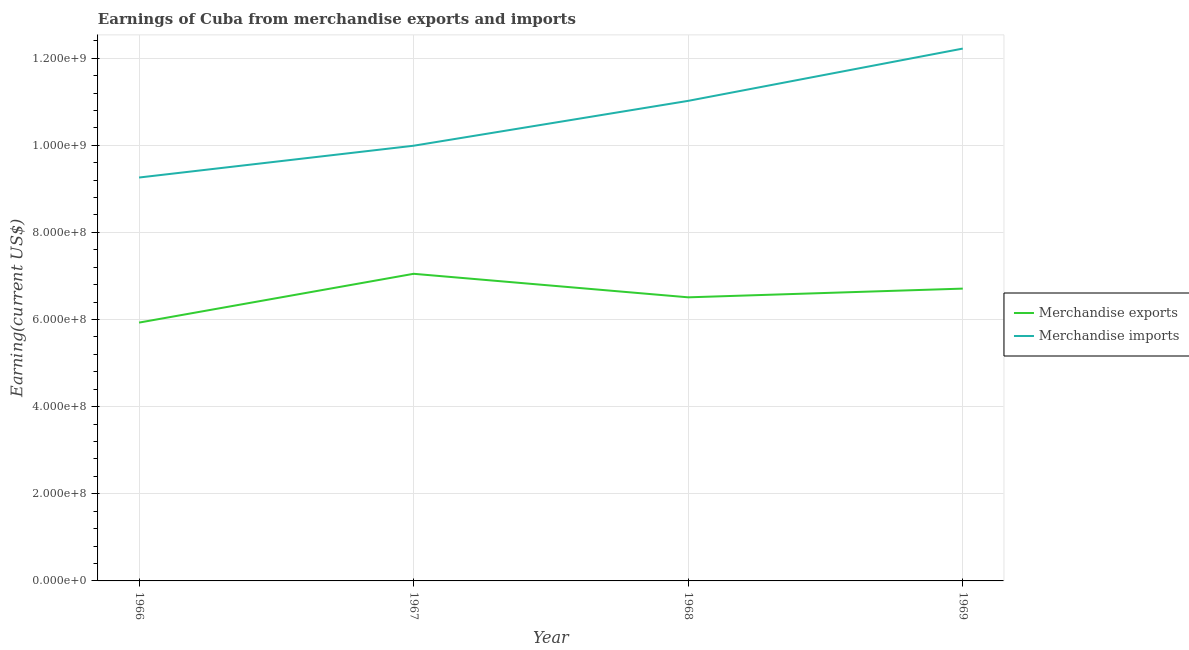How many different coloured lines are there?
Your response must be concise. 2. Is the number of lines equal to the number of legend labels?
Provide a short and direct response. Yes. What is the earnings from merchandise exports in 1966?
Ensure brevity in your answer.  5.93e+08. Across all years, what is the maximum earnings from merchandise exports?
Offer a terse response. 7.05e+08. Across all years, what is the minimum earnings from merchandise imports?
Offer a very short reply. 9.26e+08. In which year was the earnings from merchandise exports maximum?
Your answer should be very brief. 1967. In which year was the earnings from merchandise imports minimum?
Make the answer very short. 1966. What is the total earnings from merchandise imports in the graph?
Ensure brevity in your answer.  4.25e+09. What is the difference between the earnings from merchandise imports in 1966 and that in 1969?
Provide a short and direct response. -2.96e+08. What is the difference between the earnings from merchandise imports in 1969 and the earnings from merchandise exports in 1967?
Ensure brevity in your answer.  5.17e+08. What is the average earnings from merchandise imports per year?
Provide a short and direct response. 1.06e+09. In the year 1967, what is the difference between the earnings from merchandise exports and earnings from merchandise imports?
Provide a succinct answer. -2.94e+08. What is the ratio of the earnings from merchandise imports in 1967 to that in 1968?
Your response must be concise. 0.91. What is the difference between the highest and the second highest earnings from merchandise exports?
Your answer should be compact. 3.40e+07. What is the difference between the highest and the lowest earnings from merchandise imports?
Make the answer very short. 2.96e+08. In how many years, is the earnings from merchandise imports greater than the average earnings from merchandise imports taken over all years?
Give a very brief answer. 2. Is the earnings from merchandise exports strictly greater than the earnings from merchandise imports over the years?
Keep it short and to the point. No. Is the earnings from merchandise exports strictly less than the earnings from merchandise imports over the years?
Offer a very short reply. Yes. How many lines are there?
Offer a terse response. 2. Where does the legend appear in the graph?
Give a very brief answer. Center right. How are the legend labels stacked?
Provide a short and direct response. Vertical. What is the title of the graph?
Your response must be concise. Earnings of Cuba from merchandise exports and imports. Does "Exports" appear as one of the legend labels in the graph?
Keep it short and to the point. No. What is the label or title of the X-axis?
Ensure brevity in your answer.  Year. What is the label or title of the Y-axis?
Offer a very short reply. Earning(current US$). What is the Earning(current US$) of Merchandise exports in 1966?
Offer a terse response. 5.93e+08. What is the Earning(current US$) in Merchandise imports in 1966?
Your answer should be very brief. 9.26e+08. What is the Earning(current US$) of Merchandise exports in 1967?
Your answer should be compact. 7.05e+08. What is the Earning(current US$) of Merchandise imports in 1967?
Offer a very short reply. 9.99e+08. What is the Earning(current US$) of Merchandise exports in 1968?
Your answer should be very brief. 6.51e+08. What is the Earning(current US$) in Merchandise imports in 1968?
Offer a very short reply. 1.10e+09. What is the Earning(current US$) of Merchandise exports in 1969?
Offer a very short reply. 6.71e+08. What is the Earning(current US$) in Merchandise imports in 1969?
Offer a terse response. 1.22e+09. Across all years, what is the maximum Earning(current US$) of Merchandise exports?
Your answer should be compact. 7.05e+08. Across all years, what is the maximum Earning(current US$) of Merchandise imports?
Offer a terse response. 1.22e+09. Across all years, what is the minimum Earning(current US$) in Merchandise exports?
Ensure brevity in your answer.  5.93e+08. Across all years, what is the minimum Earning(current US$) in Merchandise imports?
Give a very brief answer. 9.26e+08. What is the total Earning(current US$) in Merchandise exports in the graph?
Provide a short and direct response. 2.62e+09. What is the total Earning(current US$) of Merchandise imports in the graph?
Make the answer very short. 4.25e+09. What is the difference between the Earning(current US$) of Merchandise exports in 1966 and that in 1967?
Your response must be concise. -1.12e+08. What is the difference between the Earning(current US$) in Merchandise imports in 1966 and that in 1967?
Keep it short and to the point. -7.30e+07. What is the difference between the Earning(current US$) in Merchandise exports in 1966 and that in 1968?
Make the answer very short. -5.80e+07. What is the difference between the Earning(current US$) in Merchandise imports in 1966 and that in 1968?
Provide a short and direct response. -1.76e+08. What is the difference between the Earning(current US$) in Merchandise exports in 1966 and that in 1969?
Ensure brevity in your answer.  -7.80e+07. What is the difference between the Earning(current US$) in Merchandise imports in 1966 and that in 1969?
Ensure brevity in your answer.  -2.96e+08. What is the difference between the Earning(current US$) in Merchandise exports in 1967 and that in 1968?
Offer a terse response. 5.40e+07. What is the difference between the Earning(current US$) in Merchandise imports in 1967 and that in 1968?
Your response must be concise. -1.03e+08. What is the difference between the Earning(current US$) in Merchandise exports in 1967 and that in 1969?
Provide a short and direct response. 3.40e+07. What is the difference between the Earning(current US$) in Merchandise imports in 1967 and that in 1969?
Your response must be concise. -2.23e+08. What is the difference between the Earning(current US$) in Merchandise exports in 1968 and that in 1969?
Provide a short and direct response. -2.00e+07. What is the difference between the Earning(current US$) of Merchandise imports in 1968 and that in 1969?
Make the answer very short. -1.20e+08. What is the difference between the Earning(current US$) of Merchandise exports in 1966 and the Earning(current US$) of Merchandise imports in 1967?
Make the answer very short. -4.06e+08. What is the difference between the Earning(current US$) of Merchandise exports in 1966 and the Earning(current US$) of Merchandise imports in 1968?
Your answer should be very brief. -5.09e+08. What is the difference between the Earning(current US$) in Merchandise exports in 1966 and the Earning(current US$) in Merchandise imports in 1969?
Your answer should be compact. -6.29e+08. What is the difference between the Earning(current US$) of Merchandise exports in 1967 and the Earning(current US$) of Merchandise imports in 1968?
Make the answer very short. -3.97e+08. What is the difference between the Earning(current US$) in Merchandise exports in 1967 and the Earning(current US$) in Merchandise imports in 1969?
Offer a very short reply. -5.17e+08. What is the difference between the Earning(current US$) in Merchandise exports in 1968 and the Earning(current US$) in Merchandise imports in 1969?
Your answer should be compact. -5.71e+08. What is the average Earning(current US$) of Merchandise exports per year?
Give a very brief answer. 6.55e+08. What is the average Earning(current US$) of Merchandise imports per year?
Your answer should be compact. 1.06e+09. In the year 1966, what is the difference between the Earning(current US$) of Merchandise exports and Earning(current US$) of Merchandise imports?
Give a very brief answer. -3.33e+08. In the year 1967, what is the difference between the Earning(current US$) of Merchandise exports and Earning(current US$) of Merchandise imports?
Provide a succinct answer. -2.94e+08. In the year 1968, what is the difference between the Earning(current US$) of Merchandise exports and Earning(current US$) of Merchandise imports?
Your answer should be very brief. -4.51e+08. In the year 1969, what is the difference between the Earning(current US$) in Merchandise exports and Earning(current US$) in Merchandise imports?
Offer a terse response. -5.51e+08. What is the ratio of the Earning(current US$) of Merchandise exports in 1966 to that in 1967?
Offer a very short reply. 0.84. What is the ratio of the Earning(current US$) of Merchandise imports in 1966 to that in 1967?
Provide a short and direct response. 0.93. What is the ratio of the Earning(current US$) of Merchandise exports in 1966 to that in 1968?
Keep it short and to the point. 0.91. What is the ratio of the Earning(current US$) in Merchandise imports in 1966 to that in 1968?
Offer a terse response. 0.84. What is the ratio of the Earning(current US$) in Merchandise exports in 1966 to that in 1969?
Give a very brief answer. 0.88. What is the ratio of the Earning(current US$) of Merchandise imports in 1966 to that in 1969?
Your answer should be very brief. 0.76. What is the ratio of the Earning(current US$) in Merchandise exports in 1967 to that in 1968?
Provide a succinct answer. 1.08. What is the ratio of the Earning(current US$) of Merchandise imports in 1967 to that in 1968?
Keep it short and to the point. 0.91. What is the ratio of the Earning(current US$) of Merchandise exports in 1967 to that in 1969?
Offer a terse response. 1.05. What is the ratio of the Earning(current US$) in Merchandise imports in 1967 to that in 1969?
Keep it short and to the point. 0.82. What is the ratio of the Earning(current US$) of Merchandise exports in 1968 to that in 1969?
Provide a short and direct response. 0.97. What is the ratio of the Earning(current US$) in Merchandise imports in 1968 to that in 1969?
Offer a terse response. 0.9. What is the difference between the highest and the second highest Earning(current US$) in Merchandise exports?
Your answer should be compact. 3.40e+07. What is the difference between the highest and the second highest Earning(current US$) in Merchandise imports?
Your answer should be very brief. 1.20e+08. What is the difference between the highest and the lowest Earning(current US$) in Merchandise exports?
Offer a terse response. 1.12e+08. What is the difference between the highest and the lowest Earning(current US$) of Merchandise imports?
Provide a short and direct response. 2.96e+08. 